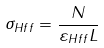Convert formula to latex. <formula><loc_0><loc_0><loc_500><loc_500>\sigma _ { H f f } = \frac { N } { \varepsilon _ { H f f } L }</formula> 